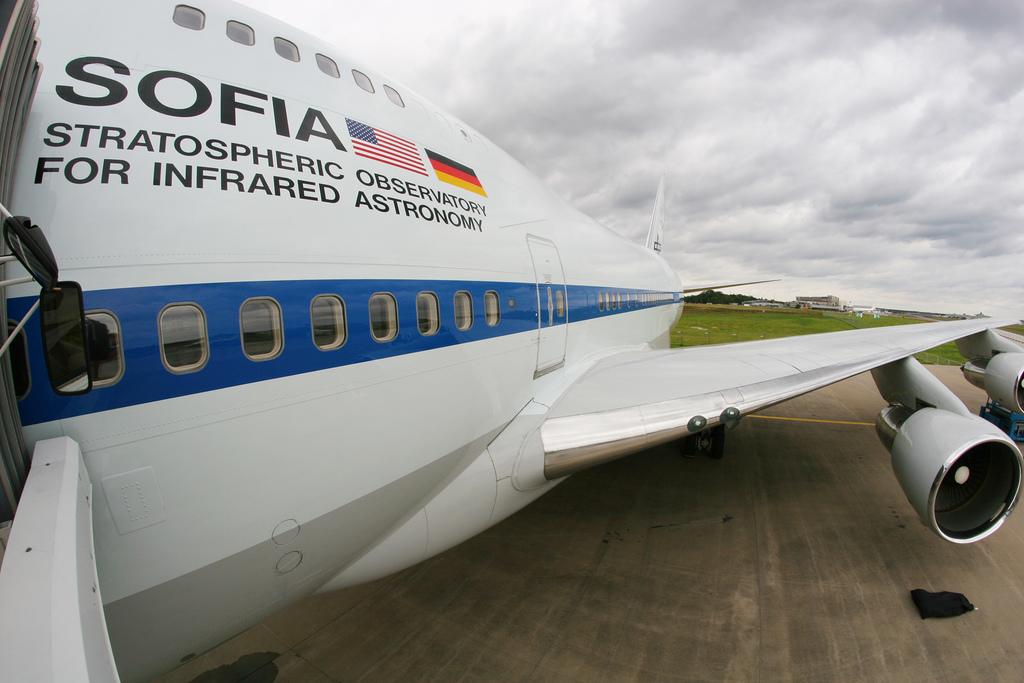What is the name of the plane?
Give a very brief answer. Sofia. 